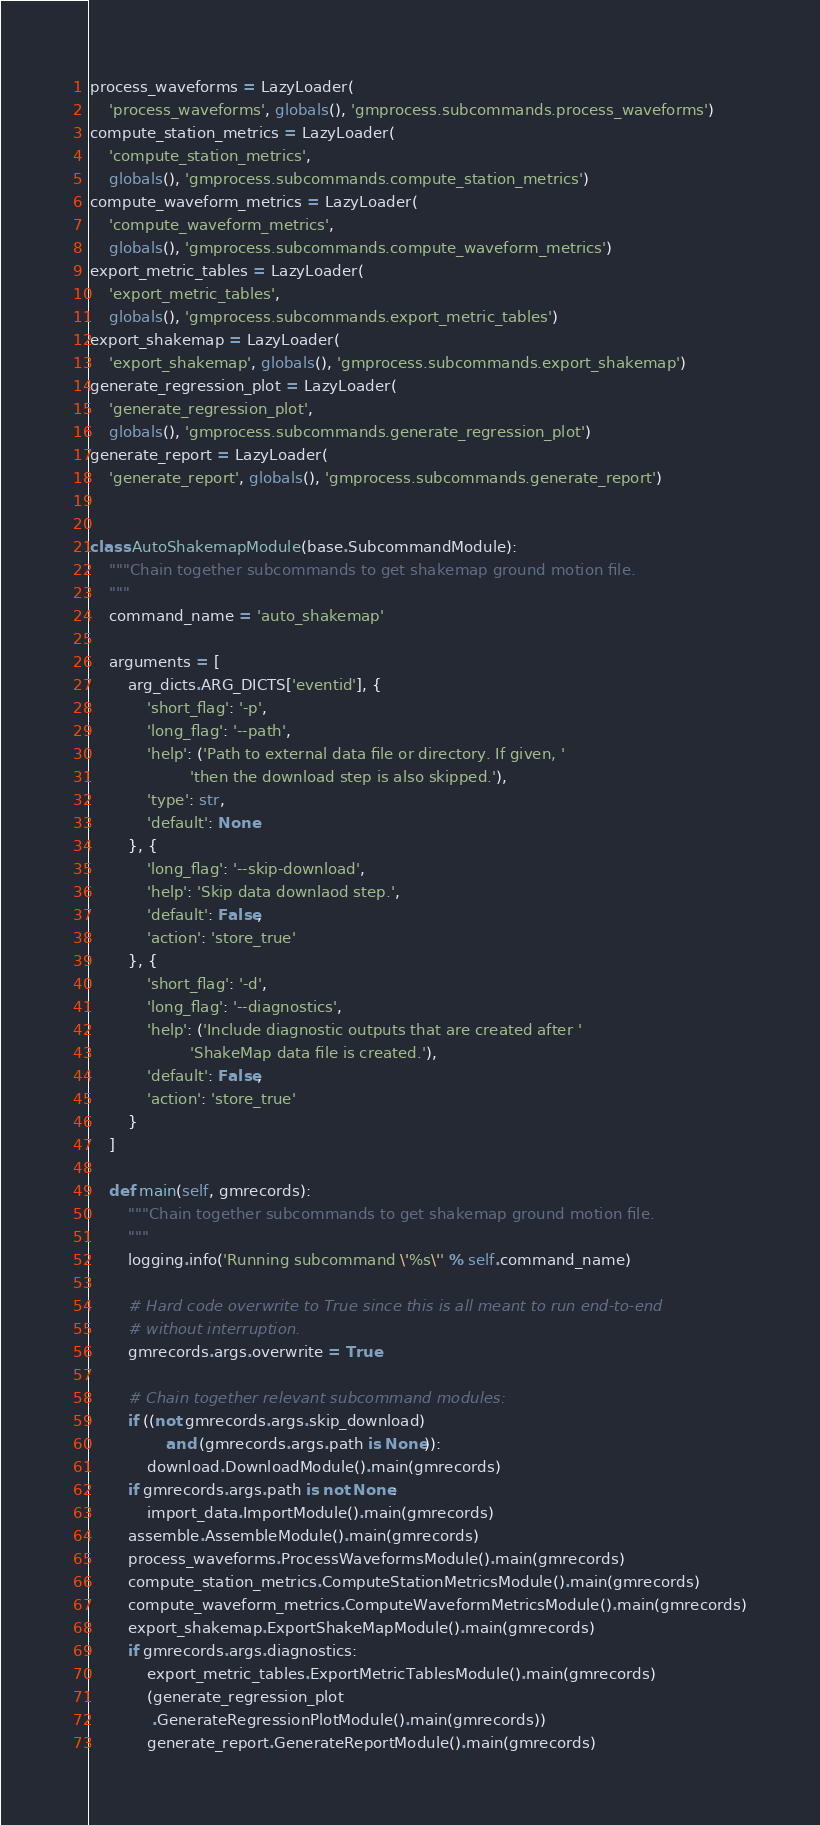<code> <loc_0><loc_0><loc_500><loc_500><_Python_>process_waveforms = LazyLoader(
    'process_waveforms', globals(), 'gmprocess.subcommands.process_waveforms')
compute_station_metrics = LazyLoader(
    'compute_station_metrics',
    globals(), 'gmprocess.subcommands.compute_station_metrics')
compute_waveform_metrics = LazyLoader(
    'compute_waveform_metrics',
    globals(), 'gmprocess.subcommands.compute_waveform_metrics')
export_metric_tables = LazyLoader(
    'export_metric_tables',
    globals(), 'gmprocess.subcommands.export_metric_tables')
export_shakemap = LazyLoader(
    'export_shakemap', globals(), 'gmprocess.subcommands.export_shakemap')
generate_regression_plot = LazyLoader(
    'generate_regression_plot',
    globals(), 'gmprocess.subcommands.generate_regression_plot')
generate_report = LazyLoader(
    'generate_report', globals(), 'gmprocess.subcommands.generate_report')


class AutoShakemapModule(base.SubcommandModule):
    """Chain together subcommands to get shakemap ground motion file.
    """
    command_name = 'auto_shakemap'

    arguments = [
        arg_dicts.ARG_DICTS['eventid'], {
            'short_flag': '-p',
            'long_flag': '--path',
            'help': ('Path to external data file or directory. If given, '
                     'then the download step is also skipped.'),
            'type': str,
            'default': None
        }, {
            'long_flag': '--skip-download',
            'help': 'Skip data downlaod step.',
            'default': False,
            'action': 'store_true'
        }, {
            'short_flag': '-d',
            'long_flag': '--diagnostics',
            'help': ('Include diagnostic outputs that are created after '
                     'ShakeMap data file is created.'),
            'default': False,
            'action': 'store_true'
        }
    ]

    def main(self, gmrecords):
        """Chain together subcommands to get shakemap ground motion file.
        """
        logging.info('Running subcommand \'%s\'' % self.command_name)

        # Hard code overwrite to True since this is all meant to run end-to-end
        # without interruption.
        gmrecords.args.overwrite = True

        # Chain together relevant subcommand modules:
        if ((not gmrecords.args.skip_download)
                and (gmrecords.args.path is None)):
            download.DownloadModule().main(gmrecords)
        if gmrecords.args.path is not None:
            import_data.ImportModule().main(gmrecords)
        assemble.AssembleModule().main(gmrecords)
        process_waveforms.ProcessWaveformsModule().main(gmrecords)
        compute_station_metrics.ComputeStationMetricsModule().main(gmrecords)
        compute_waveform_metrics.ComputeWaveformMetricsModule().main(gmrecords)
        export_shakemap.ExportShakeMapModule().main(gmrecords)
        if gmrecords.args.diagnostics:
            export_metric_tables.ExportMetricTablesModule().main(gmrecords)
            (generate_regression_plot
             .GenerateRegressionPlotModule().main(gmrecords))
            generate_report.GenerateReportModule().main(gmrecords)
</code> 